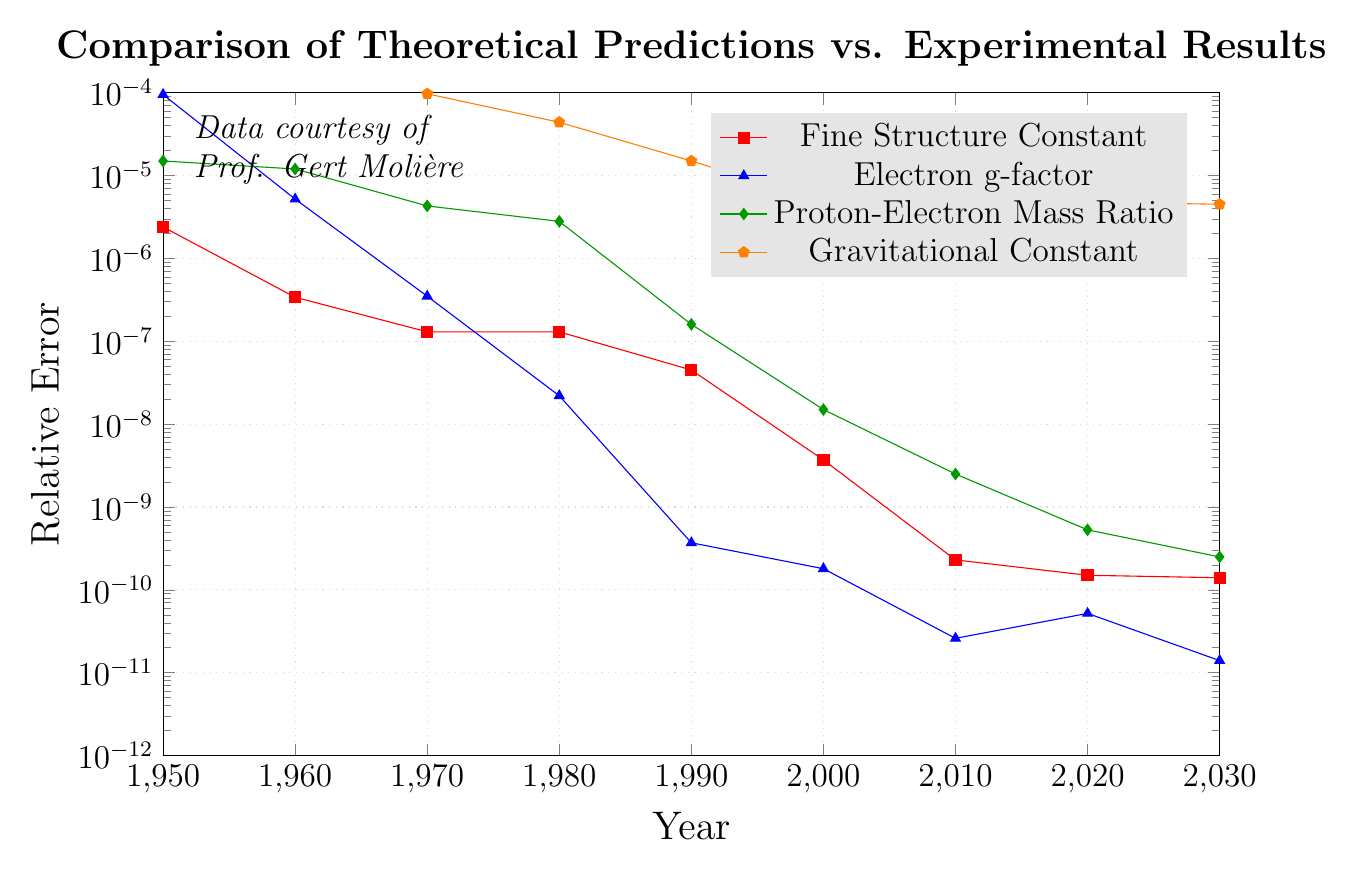What is the relative error of the Fine Structure Constant in 2020? To find the relative error of the Fine Structure Constant in 2020, look at the data point associated with the 'Fine Structure Constant' series in the year 2020. It's given as 1.5e-10.
Answer: 1.5e-10 Which constant had the largest relative error in 1950? To determine the constant with the largest relative error in 1950, compare the values for all constants in that year: Fine Structure Constant (2.4e-6), Electron g-factor (9.5e-5), Proton-Electron Mass Ratio (1.5e-5), Gravitational Constant (4.9e-4). The Gravitational Constant has the largest relative error.
Answer: Gravitational Constant What trend do you observe in the relative error of the Electron g-factor from 1950 to 2030? Observing the data points for the Electron g-factor over time, the relative error decreases consistently: 9.5e-5 (1950), 5.2e-6 (1960), 3.5e-7 (1970), 2.2e-8 (1980), 3.7e-10 (1990), 1.8e-10 (2000), 2.6e-11 (2010), 5.2e-11 (2020), and 1.4e-11 (2030).
Answer: Decreasing By how much did the relative error of the Proton-Electron Mass Ratio decrease between 1960 and 2000? First, find the relative errors for the Proton-Electron Mass Ratio in 1960 (1.2e-5) and 2000 (1.5e-8). The decrease is 1.2e-5 - 1.5e-8 = 1.1985e-5.
Answer: 1.1985e-5 Which constant usually shows the smallest relative error, and which year had the lowest error? Comparing the relative errors across constants over the years, observe that the Fine Structure Constant generally has the smallest relative errors. In 2030, its relative error is 1.4e-10, which appears to be the lowest value in the dataset.
Answer: Fine Structure Constant; 2030 How does the magnitude of the relative error of the Gravitational Constant in 1970 compare to the Proton-Electron Mass Ratio and Fine Structure Constant in the same year? For the year 1970, the relative errors are: Gravitational Constant (9.7e-5), Proton-Electron Mass Ratio (4.3e-6), Fine Structure Constant (1.3e-7). The relative error of the Gravitational Constant is greater than that of both the Proton-Electron Mass Ratio and Fine Structure Constant by comparing the magnitudes directly.
Answer: Greater In which decade did the Electron g-factor show the most significant improvement in relative error? Compare the relative error improvements for the Electron g-factor across different decades. The most significant relative improvement occurs between 1950 (9.5e-5) and 1960 (5.2e-6), where the decrease is approximately 9.48e-5.
Answer: 1950s In 1990, arrange the constants in ascending order of their relative errors. For 1990, the relative errors are: Fine Structure Constant (4.5e-8), Electron g-factor (3.7e-10), Proton-Electron Mass Ratio (1.6e-7), Gravitational Constant (1.5e-5). Arranging them in ascending order: Electron g-factor, Fine Structure Constant, Proton-Electron Mass Ratio, Gravitational Constant.
Answer: Electron g-factor, Fine Structure Constant, Proton-Electron Mass Ratio, Gravitational Constant 